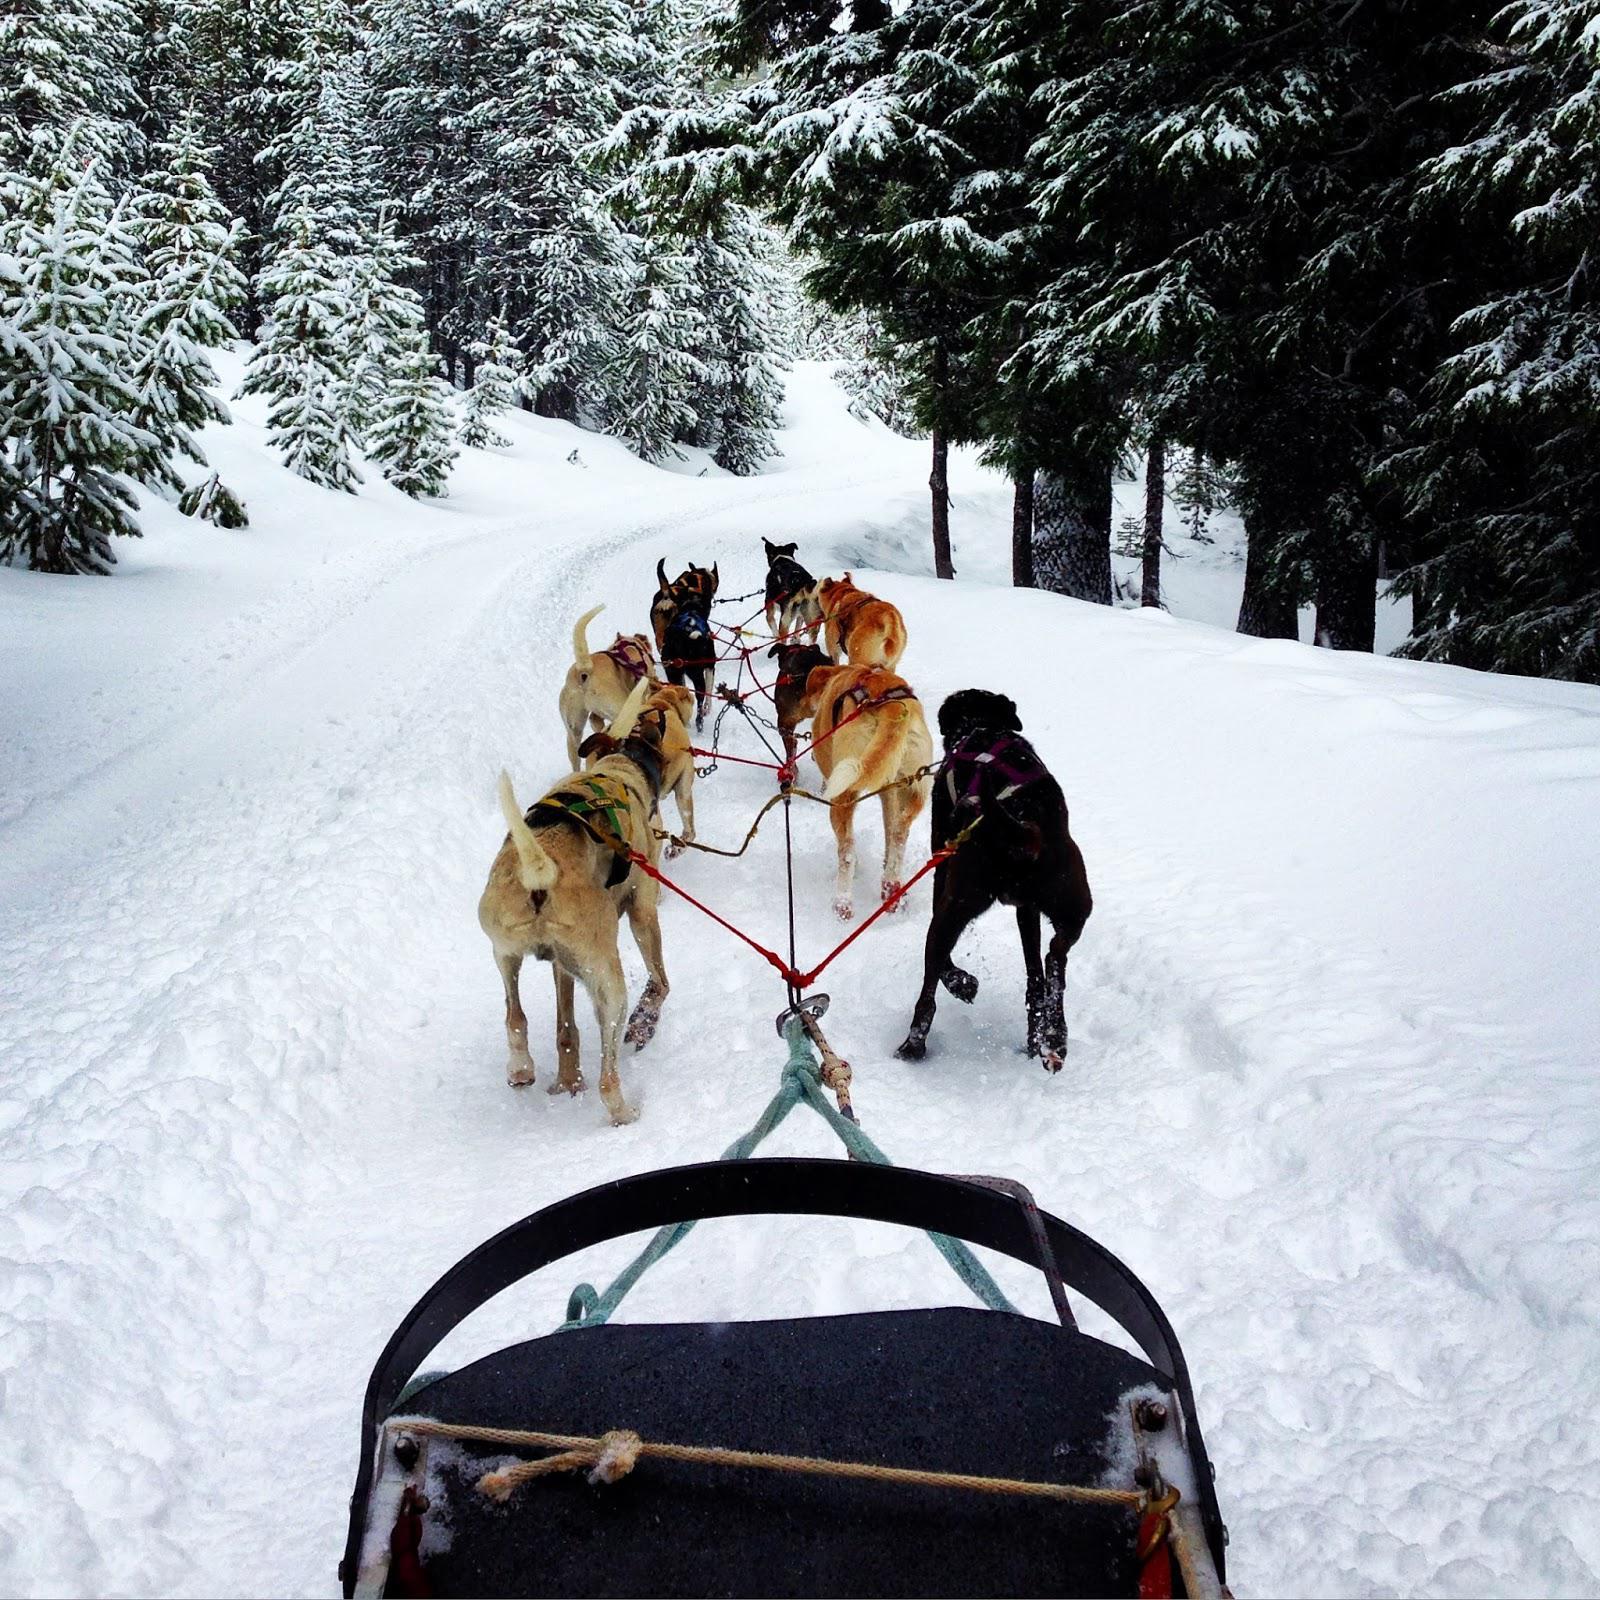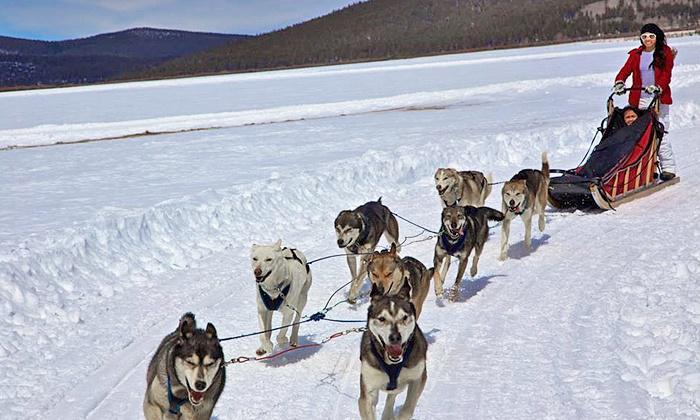The first image is the image on the left, the second image is the image on the right. Analyze the images presented: Is the assertion "There is a person with a red coat in one of the images." valid? Answer yes or no. Yes. The first image is the image on the left, the second image is the image on the right. Examine the images to the left and right. Is the description "All of the dogs are standing and at least some of the dogs are running." accurate? Answer yes or no. Yes. 